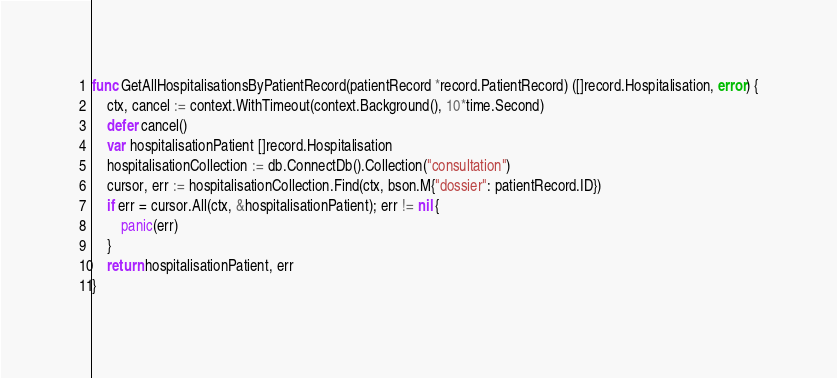<code> <loc_0><loc_0><loc_500><loc_500><_Go_>func GetAllHospitalisationsByPatientRecord(patientRecord *record.PatientRecord) ([]record.Hospitalisation, error) {
	ctx, cancel := context.WithTimeout(context.Background(), 10*time.Second)
	defer cancel()
	var hospitalisationPatient []record.Hospitalisation
	hospitalisationCollection := db.ConnectDb().Collection("consultation")
	cursor, err := hospitalisationCollection.Find(ctx, bson.M{"dossier": patientRecord.ID})
	if err = cursor.All(ctx, &hospitalisationPatient); err != nil {
		panic(err)
	}
	return hospitalisationPatient, err
}
</code> 